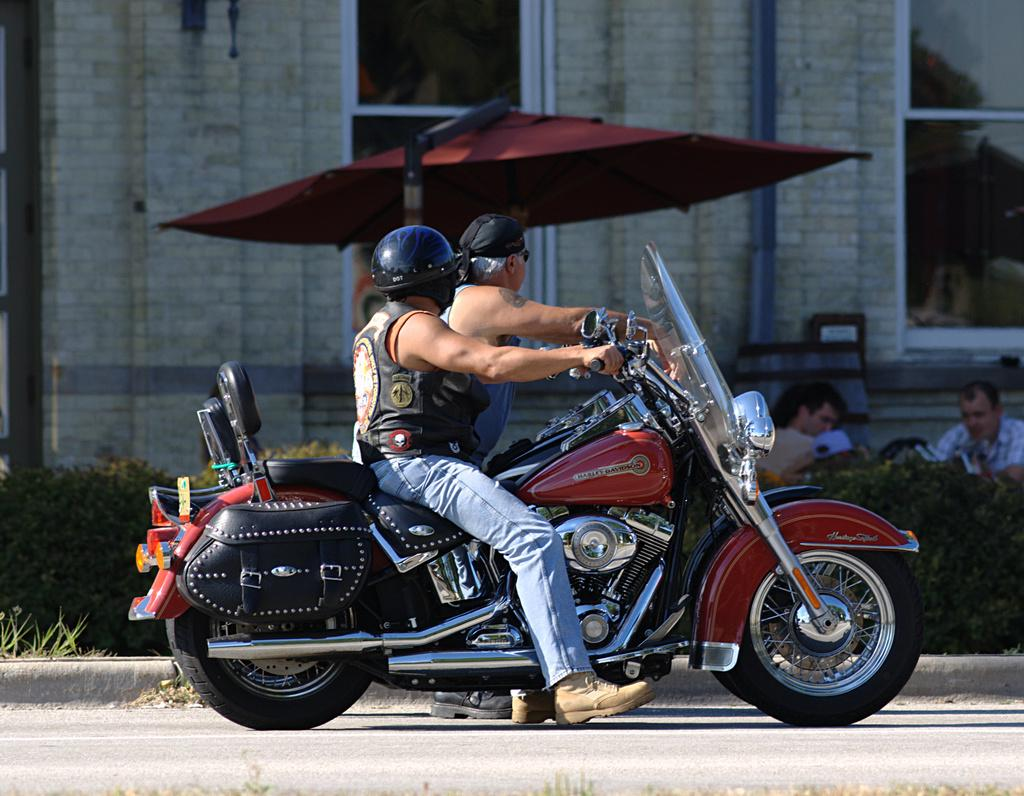How many people are on the bike in the image? There are four people on the bike in the image. What is the purpose of the object above the people on the bike? There is an umbrella in the image, which is likely used for shade or protection from the elements. What can be seen in the background of the image? There is a wall in the image. Are there any plants visible in the image? Yes, there is a plant in the image. What type of hair is visible on the plant in the image? There is no hair visible on the plant in the image, as plants do not have hair. 